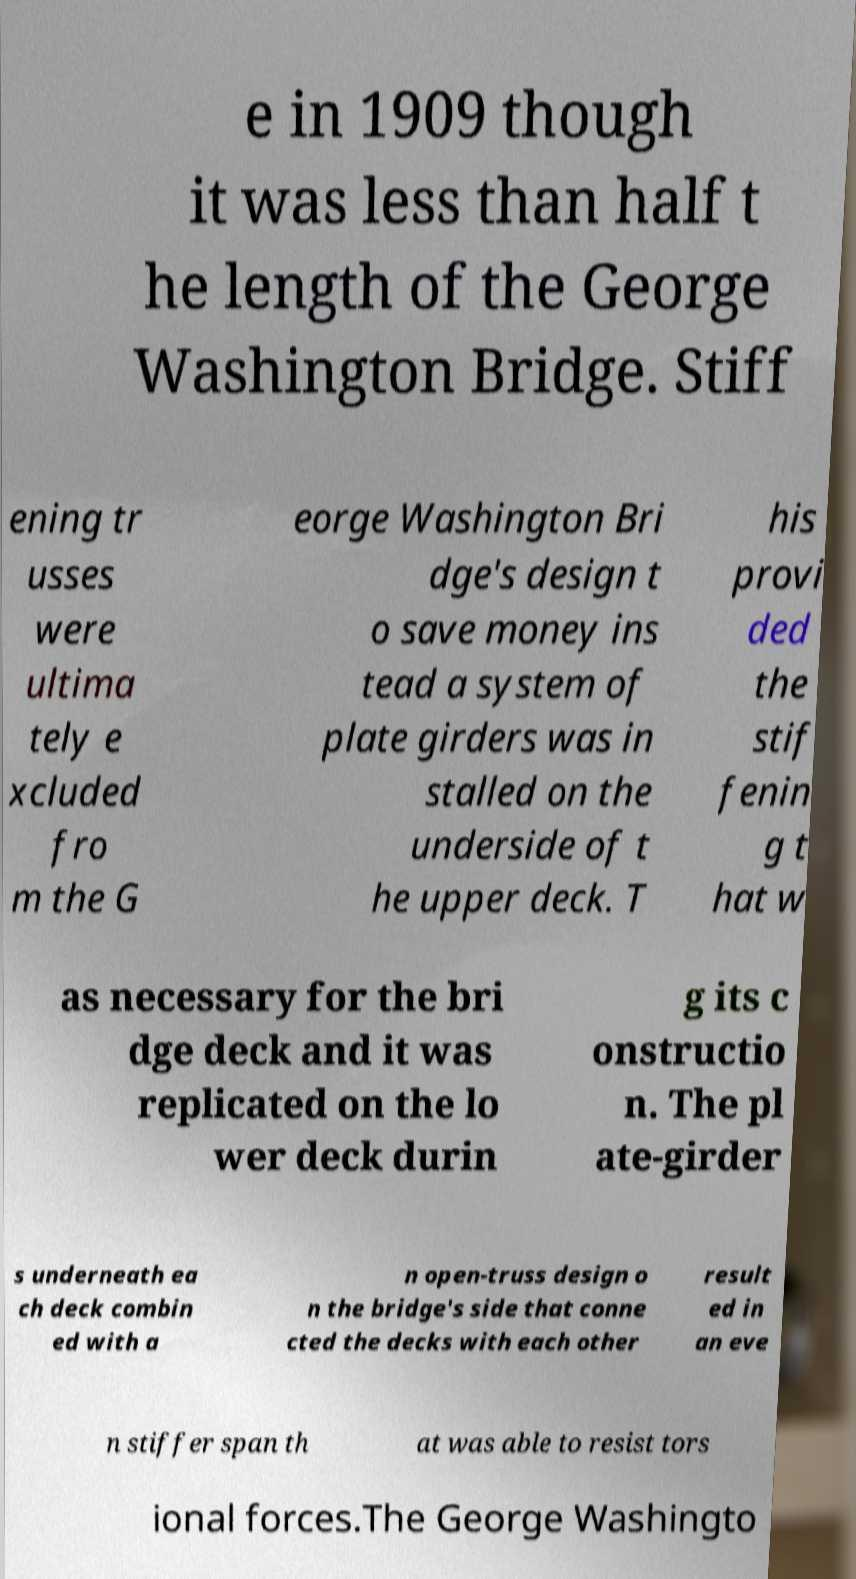I need the written content from this picture converted into text. Can you do that? e in 1909 though it was less than half t he length of the George Washington Bridge. Stiff ening tr usses were ultima tely e xcluded fro m the G eorge Washington Bri dge's design t o save money ins tead a system of plate girders was in stalled on the underside of t he upper deck. T his provi ded the stif fenin g t hat w as necessary for the bri dge deck and it was replicated on the lo wer deck durin g its c onstructio n. The pl ate-girder s underneath ea ch deck combin ed with a n open-truss design o n the bridge's side that conne cted the decks with each other result ed in an eve n stiffer span th at was able to resist tors ional forces.The George Washingto 